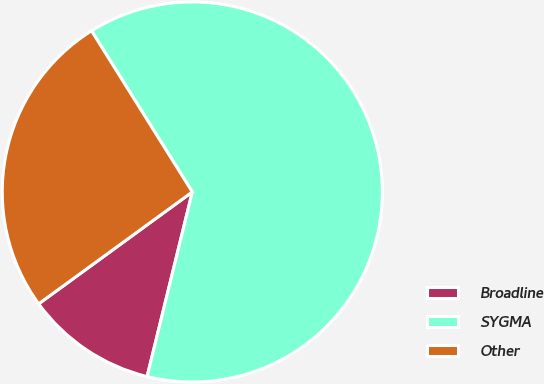<chart> <loc_0><loc_0><loc_500><loc_500><pie_chart><fcel>Broadline<fcel>SYGMA<fcel>Other<nl><fcel>11.16%<fcel>62.72%<fcel>26.12%<nl></chart> 